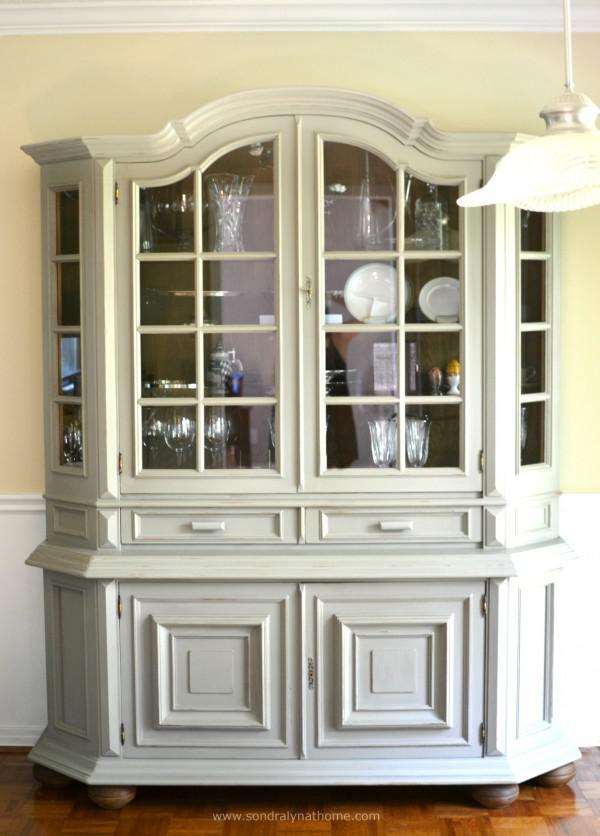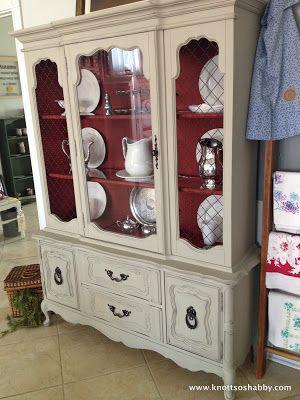The first image is the image on the left, the second image is the image on the right. Assess this claim about the two images: "All cabinets pictured have flat tops, and the right-hand cabinet sits flush on the floor without legs.". Correct or not? Answer yes or no. No. 